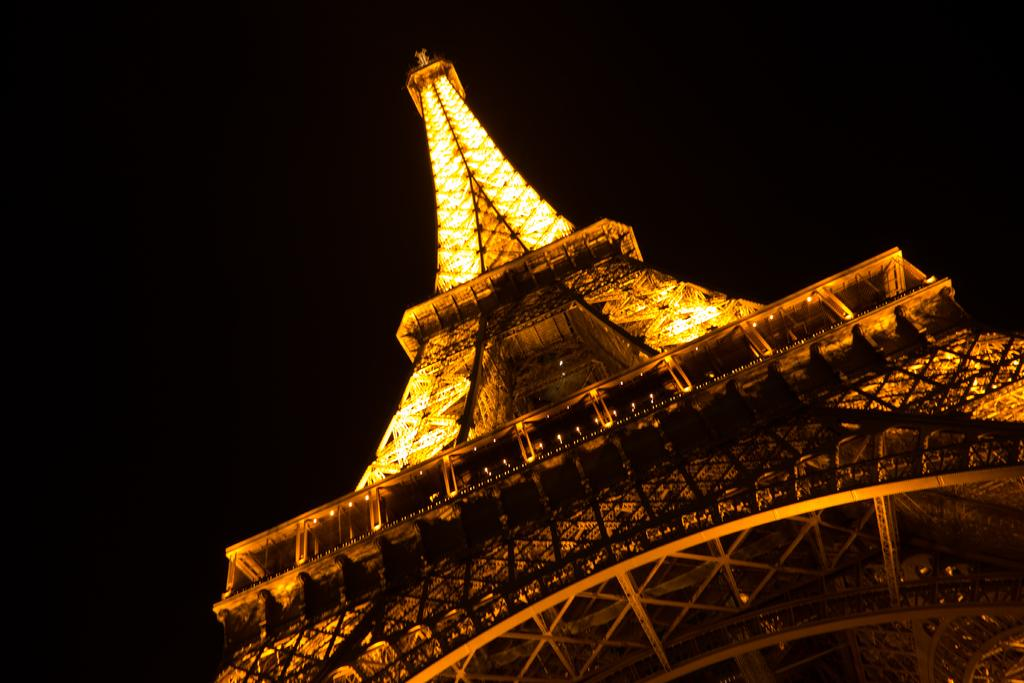Where was the picture taken? The picture was clicked outside. What is the main subject in the foreground of the image? There is a tower in the foreground of the image. What can be seen illuminated in the image? There are lights visible in the image. What is visible in the background of the image? There is a sky visible in the background of the image. What type of ornament is hanging from the tower in the image? There is no ornament hanging from the tower in the image. How is the hose connected to the tower in the image? There is no hose present in the image. 